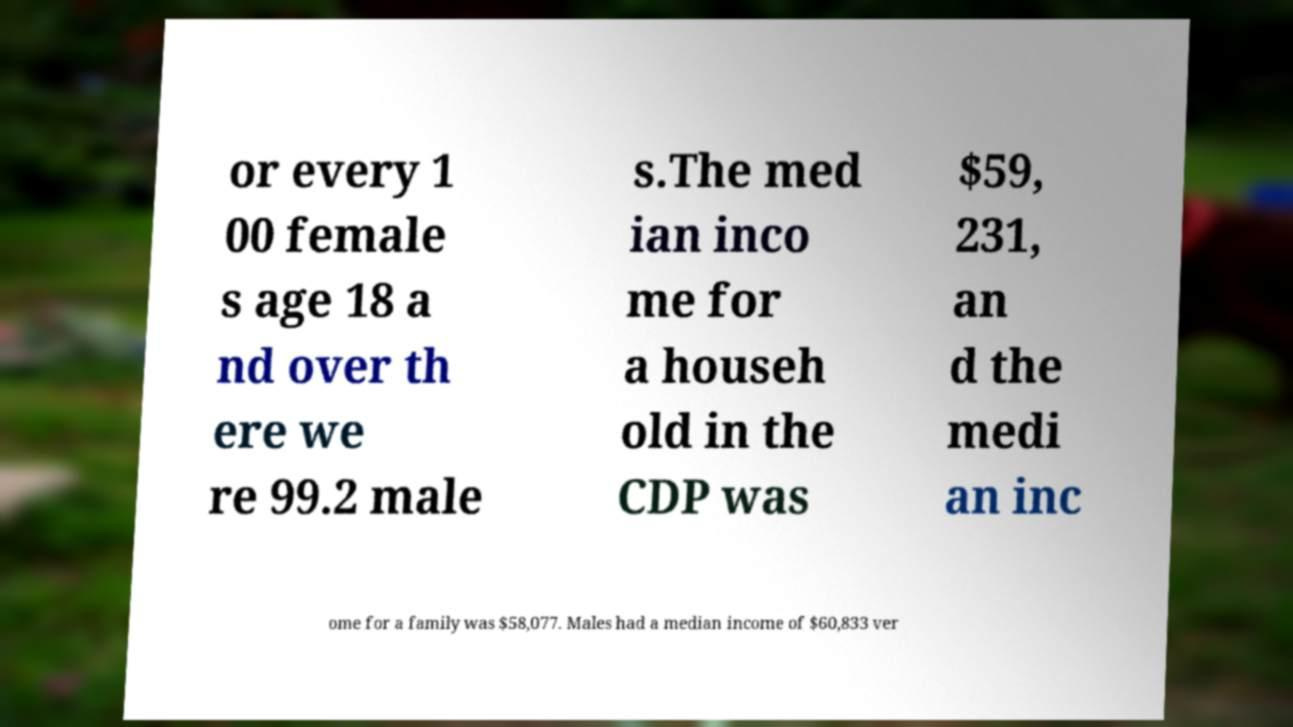Could you extract and type out the text from this image? or every 1 00 female s age 18 a nd over th ere we re 99.2 male s.The med ian inco me for a househ old in the CDP was $59, 231, an d the medi an inc ome for a family was $58,077. Males had a median income of $60,833 ver 